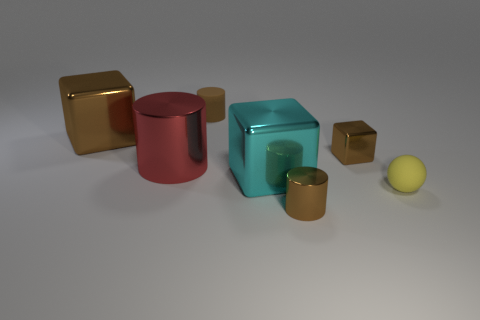There is another small cylinder that is the same color as the tiny rubber cylinder; what is its material?
Ensure brevity in your answer.  Metal. Is the number of big metal cylinders that are to the left of the small rubber sphere greater than the number of tiny brown cylinders that are behind the small metallic cylinder?
Make the answer very short. No. There is a large thing left of the red cylinder; does it have the same color as the small sphere?
Provide a succinct answer. No. What is the size of the yellow rubber thing?
Ensure brevity in your answer.  Small. There is a brown object that is the same size as the cyan thing; what material is it?
Provide a short and direct response. Metal. There is a metallic block that is to the right of the big cyan block; what is its color?
Your answer should be very brief. Brown. How many tiny red balls are there?
Your response must be concise. 0. There is a metal block that is left of the large shiny block right of the red metallic object; are there any blocks in front of it?
Make the answer very short. Yes. There is a brown thing that is the same size as the red thing; what shape is it?
Provide a succinct answer. Cube. How many other objects are the same color as the small block?
Your answer should be compact. 3. 